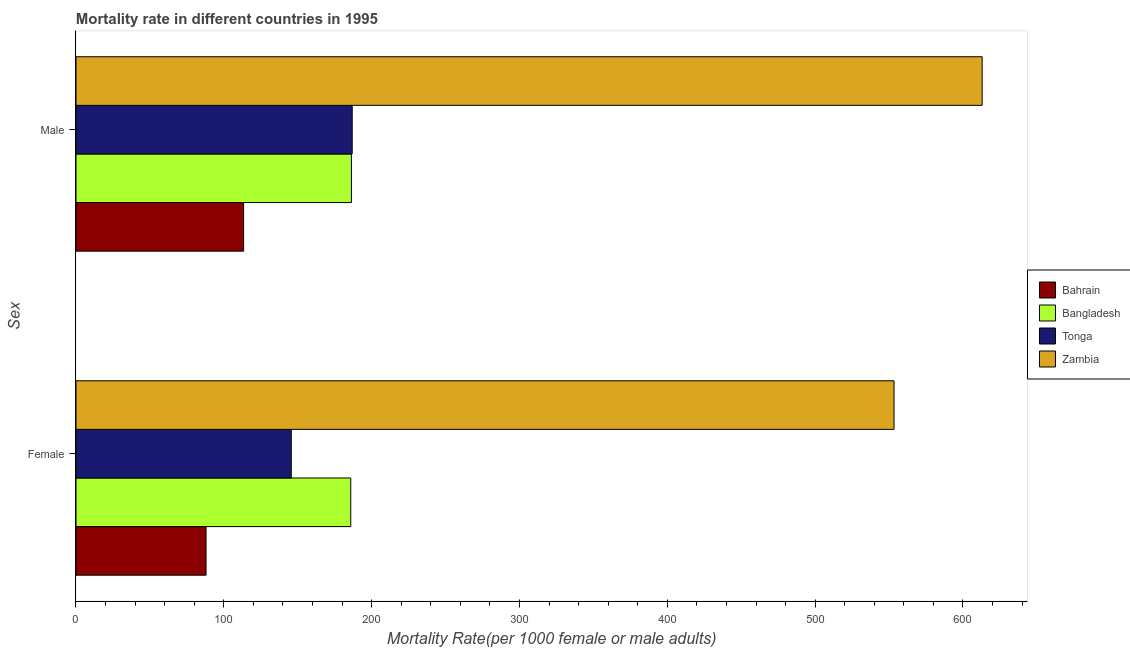How many groups of bars are there?
Make the answer very short. 2. Are the number of bars per tick equal to the number of legend labels?
Keep it short and to the point. Yes. How many bars are there on the 1st tick from the top?
Your answer should be very brief. 4. How many bars are there on the 1st tick from the bottom?
Provide a succinct answer. 4. What is the label of the 1st group of bars from the top?
Offer a terse response. Male. What is the female mortality rate in Bahrain?
Ensure brevity in your answer.  87.98. Across all countries, what is the maximum male mortality rate?
Give a very brief answer. 612.98. Across all countries, what is the minimum male mortality rate?
Ensure brevity in your answer.  113.38. In which country was the female mortality rate maximum?
Ensure brevity in your answer.  Zambia. In which country was the female mortality rate minimum?
Provide a short and direct response. Bahrain. What is the total male mortality rate in the graph?
Offer a terse response. 1099.54. What is the difference between the female mortality rate in Bangladesh and that in Tonga?
Keep it short and to the point. 40.23. What is the difference between the female mortality rate in Bangladesh and the male mortality rate in Bahrain?
Make the answer very short. 72.48. What is the average female mortality rate per country?
Give a very brief answer. 243.21. What is the difference between the male mortality rate and female mortality rate in Bangladesh?
Ensure brevity in your answer.  0.46. In how many countries, is the female mortality rate greater than 40 ?
Your answer should be compact. 4. What is the ratio of the male mortality rate in Bangladesh to that in Tonga?
Offer a very short reply. 1. Is the male mortality rate in Tonga less than that in Zambia?
Make the answer very short. Yes. What does the 2nd bar from the top in Female represents?
Your response must be concise. Tonga. What does the 4th bar from the bottom in Female represents?
Give a very brief answer. Zambia. How many bars are there?
Make the answer very short. 8. How many countries are there in the graph?
Offer a terse response. 4. What is the difference between two consecutive major ticks on the X-axis?
Your answer should be compact. 100. Does the graph contain any zero values?
Provide a succinct answer. No. Where does the legend appear in the graph?
Your answer should be very brief. Center right. What is the title of the graph?
Offer a very short reply. Mortality rate in different countries in 1995. Does "Bulgaria" appear as one of the legend labels in the graph?
Provide a short and direct response. No. What is the label or title of the X-axis?
Ensure brevity in your answer.  Mortality Rate(per 1000 female or male adults). What is the label or title of the Y-axis?
Your answer should be compact. Sex. What is the Mortality Rate(per 1000 female or male adults) in Bahrain in Female?
Keep it short and to the point. 87.98. What is the Mortality Rate(per 1000 female or male adults) of Bangladesh in Female?
Keep it short and to the point. 185.87. What is the Mortality Rate(per 1000 female or male adults) of Tonga in Female?
Your answer should be compact. 145.63. What is the Mortality Rate(per 1000 female or male adults) in Zambia in Female?
Your response must be concise. 553.38. What is the Mortality Rate(per 1000 female or male adults) in Bahrain in Male?
Your answer should be very brief. 113.38. What is the Mortality Rate(per 1000 female or male adults) in Bangladesh in Male?
Make the answer very short. 186.32. What is the Mortality Rate(per 1000 female or male adults) in Tonga in Male?
Your answer should be very brief. 186.85. What is the Mortality Rate(per 1000 female or male adults) of Zambia in Male?
Your response must be concise. 612.98. Across all Sex, what is the maximum Mortality Rate(per 1000 female or male adults) of Bahrain?
Keep it short and to the point. 113.38. Across all Sex, what is the maximum Mortality Rate(per 1000 female or male adults) in Bangladesh?
Offer a terse response. 186.32. Across all Sex, what is the maximum Mortality Rate(per 1000 female or male adults) in Tonga?
Your response must be concise. 186.85. Across all Sex, what is the maximum Mortality Rate(per 1000 female or male adults) of Zambia?
Ensure brevity in your answer.  612.98. Across all Sex, what is the minimum Mortality Rate(per 1000 female or male adults) of Bahrain?
Make the answer very short. 87.98. Across all Sex, what is the minimum Mortality Rate(per 1000 female or male adults) in Bangladesh?
Make the answer very short. 185.87. Across all Sex, what is the minimum Mortality Rate(per 1000 female or male adults) in Tonga?
Your answer should be compact. 145.63. Across all Sex, what is the minimum Mortality Rate(per 1000 female or male adults) in Zambia?
Your answer should be compact. 553.38. What is the total Mortality Rate(per 1000 female or male adults) in Bahrain in the graph?
Your response must be concise. 201.36. What is the total Mortality Rate(per 1000 female or male adults) of Bangladesh in the graph?
Ensure brevity in your answer.  372.19. What is the total Mortality Rate(per 1000 female or male adults) in Tonga in the graph?
Provide a short and direct response. 332.49. What is the total Mortality Rate(per 1000 female or male adults) of Zambia in the graph?
Your response must be concise. 1166.36. What is the difference between the Mortality Rate(per 1000 female or male adults) of Bahrain in Female and that in Male?
Provide a short and direct response. -25.41. What is the difference between the Mortality Rate(per 1000 female or male adults) in Bangladesh in Female and that in Male?
Your answer should be compact. -0.46. What is the difference between the Mortality Rate(per 1000 female or male adults) of Tonga in Female and that in Male?
Your response must be concise. -41.22. What is the difference between the Mortality Rate(per 1000 female or male adults) in Zambia in Female and that in Male?
Keep it short and to the point. -59.6. What is the difference between the Mortality Rate(per 1000 female or male adults) in Bahrain in Female and the Mortality Rate(per 1000 female or male adults) in Bangladesh in Male?
Give a very brief answer. -98.34. What is the difference between the Mortality Rate(per 1000 female or male adults) in Bahrain in Female and the Mortality Rate(per 1000 female or male adults) in Tonga in Male?
Offer a very short reply. -98.87. What is the difference between the Mortality Rate(per 1000 female or male adults) in Bahrain in Female and the Mortality Rate(per 1000 female or male adults) in Zambia in Male?
Offer a terse response. -525. What is the difference between the Mortality Rate(per 1000 female or male adults) of Bangladesh in Female and the Mortality Rate(per 1000 female or male adults) of Tonga in Male?
Keep it short and to the point. -0.99. What is the difference between the Mortality Rate(per 1000 female or male adults) of Bangladesh in Female and the Mortality Rate(per 1000 female or male adults) of Zambia in Male?
Offer a terse response. -427.12. What is the difference between the Mortality Rate(per 1000 female or male adults) of Tonga in Female and the Mortality Rate(per 1000 female or male adults) of Zambia in Male?
Offer a very short reply. -467.35. What is the average Mortality Rate(per 1000 female or male adults) of Bahrain per Sex?
Offer a terse response. 100.68. What is the average Mortality Rate(per 1000 female or male adults) of Bangladesh per Sex?
Provide a succinct answer. 186.09. What is the average Mortality Rate(per 1000 female or male adults) in Tonga per Sex?
Offer a very short reply. 166.24. What is the average Mortality Rate(per 1000 female or male adults) of Zambia per Sex?
Provide a succinct answer. 583.18. What is the difference between the Mortality Rate(per 1000 female or male adults) in Bahrain and Mortality Rate(per 1000 female or male adults) in Bangladesh in Female?
Provide a short and direct response. -97.89. What is the difference between the Mortality Rate(per 1000 female or male adults) in Bahrain and Mortality Rate(per 1000 female or male adults) in Tonga in Female?
Offer a very short reply. -57.66. What is the difference between the Mortality Rate(per 1000 female or male adults) of Bahrain and Mortality Rate(per 1000 female or male adults) of Zambia in Female?
Make the answer very short. -465.4. What is the difference between the Mortality Rate(per 1000 female or male adults) in Bangladesh and Mortality Rate(per 1000 female or male adults) in Tonga in Female?
Make the answer very short. 40.23. What is the difference between the Mortality Rate(per 1000 female or male adults) of Bangladesh and Mortality Rate(per 1000 female or male adults) of Zambia in Female?
Give a very brief answer. -367.51. What is the difference between the Mortality Rate(per 1000 female or male adults) in Tonga and Mortality Rate(per 1000 female or male adults) in Zambia in Female?
Your answer should be very brief. -407.75. What is the difference between the Mortality Rate(per 1000 female or male adults) of Bahrain and Mortality Rate(per 1000 female or male adults) of Bangladesh in Male?
Offer a very short reply. -72.94. What is the difference between the Mortality Rate(per 1000 female or male adults) of Bahrain and Mortality Rate(per 1000 female or male adults) of Tonga in Male?
Your answer should be very brief. -73.47. What is the difference between the Mortality Rate(per 1000 female or male adults) of Bahrain and Mortality Rate(per 1000 female or male adults) of Zambia in Male?
Offer a very short reply. -499.6. What is the difference between the Mortality Rate(per 1000 female or male adults) of Bangladesh and Mortality Rate(per 1000 female or male adults) of Tonga in Male?
Offer a terse response. -0.53. What is the difference between the Mortality Rate(per 1000 female or male adults) in Bangladesh and Mortality Rate(per 1000 female or male adults) in Zambia in Male?
Keep it short and to the point. -426.66. What is the difference between the Mortality Rate(per 1000 female or male adults) of Tonga and Mortality Rate(per 1000 female or male adults) of Zambia in Male?
Give a very brief answer. -426.13. What is the ratio of the Mortality Rate(per 1000 female or male adults) in Bahrain in Female to that in Male?
Provide a short and direct response. 0.78. What is the ratio of the Mortality Rate(per 1000 female or male adults) in Bangladesh in Female to that in Male?
Provide a short and direct response. 1. What is the ratio of the Mortality Rate(per 1000 female or male adults) in Tonga in Female to that in Male?
Provide a short and direct response. 0.78. What is the ratio of the Mortality Rate(per 1000 female or male adults) of Zambia in Female to that in Male?
Keep it short and to the point. 0.9. What is the difference between the highest and the second highest Mortality Rate(per 1000 female or male adults) in Bahrain?
Offer a very short reply. 25.41. What is the difference between the highest and the second highest Mortality Rate(per 1000 female or male adults) of Bangladesh?
Your answer should be very brief. 0.46. What is the difference between the highest and the second highest Mortality Rate(per 1000 female or male adults) in Tonga?
Your answer should be compact. 41.22. What is the difference between the highest and the second highest Mortality Rate(per 1000 female or male adults) in Zambia?
Offer a very short reply. 59.6. What is the difference between the highest and the lowest Mortality Rate(per 1000 female or male adults) in Bahrain?
Your answer should be very brief. 25.41. What is the difference between the highest and the lowest Mortality Rate(per 1000 female or male adults) in Bangladesh?
Your response must be concise. 0.46. What is the difference between the highest and the lowest Mortality Rate(per 1000 female or male adults) of Tonga?
Ensure brevity in your answer.  41.22. What is the difference between the highest and the lowest Mortality Rate(per 1000 female or male adults) in Zambia?
Your answer should be compact. 59.6. 